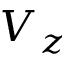Convert formula to latex. <formula><loc_0><loc_0><loc_500><loc_500>V _ { z }</formula> 